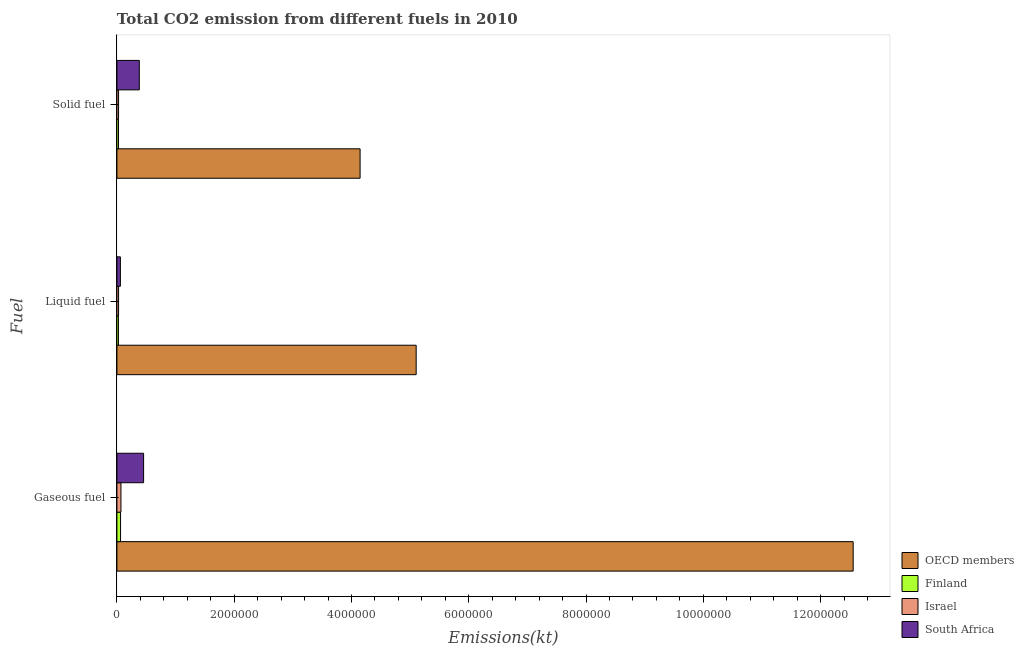How many bars are there on the 2nd tick from the bottom?
Ensure brevity in your answer.  4. What is the label of the 1st group of bars from the top?
Your response must be concise. Solid fuel. What is the amount of co2 emissions from solid fuel in South Africa?
Your response must be concise. 3.82e+05. Across all countries, what is the maximum amount of co2 emissions from solid fuel?
Offer a very short reply. 4.15e+06. Across all countries, what is the minimum amount of co2 emissions from gaseous fuel?
Offer a very short reply. 6.18e+04. In which country was the amount of co2 emissions from solid fuel minimum?
Make the answer very short. Finland. What is the total amount of co2 emissions from solid fuel in the graph?
Provide a short and direct response. 4.58e+06. What is the difference between the amount of co2 emissions from solid fuel in Finland and that in Israel?
Your response must be concise. -1166.11. What is the difference between the amount of co2 emissions from solid fuel in South Africa and the amount of co2 emissions from liquid fuel in OECD members?
Ensure brevity in your answer.  -4.72e+06. What is the average amount of co2 emissions from gaseous fuel per country?
Provide a short and direct response. 3.29e+06. What is the difference between the amount of co2 emissions from liquid fuel and amount of co2 emissions from solid fuel in OECD members?
Provide a succinct answer. 9.56e+05. What is the ratio of the amount of co2 emissions from liquid fuel in OECD members to that in South Africa?
Offer a terse response. 86.42. Is the amount of co2 emissions from solid fuel in South Africa less than that in Finland?
Your answer should be very brief. No. Is the difference between the amount of co2 emissions from solid fuel in Finland and South Africa greater than the difference between the amount of co2 emissions from gaseous fuel in Finland and South Africa?
Give a very brief answer. Yes. What is the difference between the highest and the second highest amount of co2 emissions from gaseous fuel?
Your answer should be very brief. 1.21e+07. What is the difference between the highest and the lowest amount of co2 emissions from solid fuel?
Keep it short and to the point. 4.12e+06. What does the 2nd bar from the bottom in Liquid fuel represents?
Provide a succinct answer. Finland. Is it the case that in every country, the sum of the amount of co2 emissions from gaseous fuel and amount of co2 emissions from liquid fuel is greater than the amount of co2 emissions from solid fuel?
Your response must be concise. Yes. Are all the bars in the graph horizontal?
Ensure brevity in your answer.  Yes. How many countries are there in the graph?
Your answer should be compact. 4. What is the difference between two consecutive major ticks on the X-axis?
Your answer should be compact. 2.00e+06. Are the values on the major ticks of X-axis written in scientific E-notation?
Offer a terse response. No. Does the graph contain any zero values?
Offer a very short reply. No. Where does the legend appear in the graph?
Give a very brief answer. Bottom right. How many legend labels are there?
Keep it short and to the point. 4. What is the title of the graph?
Keep it short and to the point. Total CO2 emission from different fuels in 2010. What is the label or title of the X-axis?
Offer a terse response. Emissions(kt). What is the label or title of the Y-axis?
Offer a very short reply. Fuel. What is the Emissions(kt) of OECD members in Gaseous fuel?
Give a very brief answer. 1.26e+07. What is the Emissions(kt) in Finland in Gaseous fuel?
Offer a terse response. 6.18e+04. What is the Emissions(kt) of Israel in Gaseous fuel?
Ensure brevity in your answer.  6.89e+04. What is the Emissions(kt) of South Africa in Gaseous fuel?
Provide a short and direct response. 4.55e+05. What is the Emissions(kt) of OECD members in Liquid fuel?
Your response must be concise. 5.10e+06. What is the Emissions(kt) in Finland in Liquid fuel?
Your answer should be compact. 2.56e+04. What is the Emissions(kt) of Israel in Liquid fuel?
Keep it short and to the point. 2.81e+04. What is the Emissions(kt) of South Africa in Liquid fuel?
Ensure brevity in your answer.  5.90e+04. What is the Emissions(kt) of OECD members in Solid fuel?
Offer a very short reply. 4.15e+06. What is the Emissions(kt) in Finland in Solid fuel?
Your answer should be very brief. 2.69e+04. What is the Emissions(kt) in Israel in Solid fuel?
Your answer should be very brief. 2.81e+04. What is the Emissions(kt) in South Africa in Solid fuel?
Offer a very short reply. 3.82e+05. Across all Fuel, what is the maximum Emissions(kt) of OECD members?
Keep it short and to the point. 1.26e+07. Across all Fuel, what is the maximum Emissions(kt) in Finland?
Offer a terse response. 6.18e+04. Across all Fuel, what is the maximum Emissions(kt) of Israel?
Offer a very short reply. 6.89e+04. Across all Fuel, what is the maximum Emissions(kt) in South Africa?
Your response must be concise. 4.55e+05. Across all Fuel, what is the minimum Emissions(kt) in OECD members?
Ensure brevity in your answer.  4.15e+06. Across all Fuel, what is the minimum Emissions(kt) of Finland?
Keep it short and to the point. 2.56e+04. Across all Fuel, what is the minimum Emissions(kt) in Israel?
Your answer should be compact. 2.81e+04. Across all Fuel, what is the minimum Emissions(kt) in South Africa?
Make the answer very short. 5.90e+04. What is the total Emissions(kt) in OECD members in the graph?
Make the answer very short. 2.18e+07. What is the total Emissions(kt) in Finland in the graph?
Give a very brief answer. 1.14e+05. What is the total Emissions(kt) of Israel in the graph?
Keep it short and to the point. 1.25e+05. What is the total Emissions(kt) in South Africa in the graph?
Provide a short and direct response. 8.96e+05. What is the difference between the Emissions(kt) in OECD members in Gaseous fuel and that in Liquid fuel?
Offer a very short reply. 7.45e+06. What is the difference between the Emissions(kt) in Finland in Gaseous fuel and that in Liquid fuel?
Give a very brief answer. 3.62e+04. What is the difference between the Emissions(kt) of Israel in Gaseous fuel and that in Liquid fuel?
Your response must be concise. 4.08e+04. What is the difference between the Emissions(kt) of South Africa in Gaseous fuel and that in Liquid fuel?
Provide a short and direct response. 3.96e+05. What is the difference between the Emissions(kt) of OECD members in Gaseous fuel and that in Solid fuel?
Your answer should be compact. 8.41e+06. What is the difference between the Emissions(kt) of Finland in Gaseous fuel and that in Solid fuel?
Make the answer very short. 3.49e+04. What is the difference between the Emissions(kt) in Israel in Gaseous fuel and that in Solid fuel?
Your answer should be compact. 4.08e+04. What is the difference between the Emissions(kt) of South Africa in Gaseous fuel and that in Solid fuel?
Offer a very short reply. 7.32e+04. What is the difference between the Emissions(kt) in OECD members in Liquid fuel and that in Solid fuel?
Offer a terse response. 9.56e+05. What is the difference between the Emissions(kt) of Finland in Liquid fuel and that in Solid fuel?
Your response must be concise. -1338.45. What is the difference between the Emissions(kt) of Israel in Liquid fuel and that in Solid fuel?
Your response must be concise. 36.67. What is the difference between the Emissions(kt) in South Africa in Liquid fuel and that in Solid fuel?
Your answer should be very brief. -3.23e+05. What is the difference between the Emissions(kt) of OECD members in Gaseous fuel and the Emissions(kt) of Finland in Liquid fuel?
Provide a short and direct response. 1.25e+07. What is the difference between the Emissions(kt) in OECD members in Gaseous fuel and the Emissions(kt) in Israel in Liquid fuel?
Give a very brief answer. 1.25e+07. What is the difference between the Emissions(kt) in OECD members in Gaseous fuel and the Emissions(kt) in South Africa in Liquid fuel?
Ensure brevity in your answer.  1.25e+07. What is the difference between the Emissions(kt) of Finland in Gaseous fuel and the Emissions(kt) of Israel in Liquid fuel?
Give a very brief answer. 3.37e+04. What is the difference between the Emissions(kt) of Finland in Gaseous fuel and the Emissions(kt) of South Africa in Liquid fuel?
Your response must be concise. 2794.25. What is the difference between the Emissions(kt) in Israel in Gaseous fuel and the Emissions(kt) in South Africa in Liquid fuel?
Your answer should be very brief. 9842.23. What is the difference between the Emissions(kt) in OECD members in Gaseous fuel and the Emissions(kt) in Finland in Solid fuel?
Make the answer very short. 1.25e+07. What is the difference between the Emissions(kt) in OECD members in Gaseous fuel and the Emissions(kt) in Israel in Solid fuel?
Your answer should be compact. 1.25e+07. What is the difference between the Emissions(kt) of OECD members in Gaseous fuel and the Emissions(kt) of South Africa in Solid fuel?
Provide a succinct answer. 1.22e+07. What is the difference between the Emissions(kt) of Finland in Gaseous fuel and the Emissions(kt) of Israel in Solid fuel?
Your answer should be compact. 3.37e+04. What is the difference between the Emissions(kt) of Finland in Gaseous fuel and the Emissions(kt) of South Africa in Solid fuel?
Your response must be concise. -3.20e+05. What is the difference between the Emissions(kt) in Israel in Gaseous fuel and the Emissions(kt) in South Africa in Solid fuel?
Your response must be concise. -3.13e+05. What is the difference between the Emissions(kt) of OECD members in Liquid fuel and the Emissions(kt) of Finland in Solid fuel?
Your response must be concise. 5.08e+06. What is the difference between the Emissions(kt) in OECD members in Liquid fuel and the Emissions(kt) in Israel in Solid fuel?
Your response must be concise. 5.07e+06. What is the difference between the Emissions(kt) in OECD members in Liquid fuel and the Emissions(kt) in South Africa in Solid fuel?
Provide a short and direct response. 4.72e+06. What is the difference between the Emissions(kt) of Finland in Liquid fuel and the Emissions(kt) of Israel in Solid fuel?
Make the answer very short. -2504.56. What is the difference between the Emissions(kt) of Finland in Liquid fuel and the Emissions(kt) of South Africa in Solid fuel?
Provide a succinct answer. -3.56e+05. What is the difference between the Emissions(kt) of Israel in Liquid fuel and the Emissions(kt) of South Africa in Solid fuel?
Your answer should be compact. -3.54e+05. What is the average Emissions(kt) of OECD members per Fuel?
Keep it short and to the point. 7.27e+06. What is the average Emissions(kt) of Finland per Fuel?
Provide a succinct answer. 3.81e+04. What is the average Emissions(kt) in Israel per Fuel?
Give a very brief answer. 4.17e+04. What is the average Emissions(kt) in South Africa per Fuel?
Make the answer very short. 2.99e+05. What is the difference between the Emissions(kt) of OECD members and Emissions(kt) of Finland in Gaseous fuel?
Keep it short and to the point. 1.25e+07. What is the difference between the Emissions(kt) in OECD members and Emissions(kt) in Israel in Gaseous fuel?
Your response must be concise. 1.25e+07. What is the difference between the Emissions(kt) in OECD members and Emissions(kt) in South Africa in Gaseous fuel?
Make the answer very short. 1.21e+07. What is the difference between the Emissions(kt) of Finland and Emissions(kt) of Israel in Gaseous fuel?
Keep it short and to the point. -7047.97. What is the difference between the Emissions(kt) in Finland and Emissions(kt) in South Africa in Gaseous fuel?
Make the answer very short. -3.93e+05. What is the difference between the Emissions(kt) in Israel and Emissions(kt) in South Africa in Gaseous fuel?
Keep it short and to the point. -3.86e+05. What is the difference between the Emissions(kt) in OECD members and Emissions(kt) in Finland in Liquid fuel?
Your answer should be compact. 5.08e+06. What is the difference between the Emissions(kt) in OECD members and Emissions(kt) in Israel in Liquid fuel?
Your answer should be compact. 5.07e+06. What is the difference between the Emissions(kt) in OECD members and Emissions(kt) in South Africa in Liquid fuel?
Offer a very short reply. 5.04e+06. What is the difference between the Emissions(kt) of Finland and Emissions(kt) of Israel in Liquid fuel?
Your response must be concise. -2541.23. What is the difference between the Emissions(kt) in Finland and Emissions(kt) in South Africa in Liquid fuel?
Offer a very short reply. -3.35e+04. What is the difference between the Emissions(kt) of Israel and Emissions(kt) of South Africa in Liquid fuel?
Provide a succinct answer. -3.09e+04. What is the difference between the Emissions(kt) of OECD members and Emissions(kt) of Finland in Solid fuel?
Your answer should be very brief. 4.12e+06. What is the difference between the Emissions(kt) of OECD members and Emissions(kt) of Israel in Solid fuel?
Offer a very short reply. 4.12e+06. What is the difference between the Emissions(kt) of OECD members and Emissions(kt) of South Africa in Solid fuel?
Your response must be concise. 3.76e+06. What is the difference between the Emissions(kt) in Finland and Emissions(kt) in Israel in Solid fuel?
Keep it short and to the point. -1166.11. What is the difference between the Emissions(kt) of Finland and Emissions(kt) of South Africa in Solid fuel?
Give a very brief answer. -3.55e+05. What is the difference between the Emissions(kt) in Israel and Emissions(kt) in South Africa in Solid fuel?
Give a very brief answer. -3.54e+05. What is the ratio of the Emissions(kt) of OECD members in Gaseous fuel to that in Liquid fuel?
Ensure brevity in your answer.  2.46. What is the ratio of the Emissions(kt) of Finland in Gaseous fuel to that in Liquid fuel?
Keep it short and to the point. 2.42. What is the ratio of the Emissions(kt) of Israel in Gaseous fuel to that in Liquid fuel?
Ensure brevity in your answer.  2.45. What is the ratio of the Emissions(kt) of South Africa in Gaseous fuel to that in Liquid fuel?
Your answer should be very brief. 7.7. What is the ratio of the Emissions(kt) of OECD members in Gaseous fuel to that in Solid fuel?
Your answer should be compact. 3.03. What is the ratio of the Emissions(kt) in Finland in Gaseous fuel to that in Solid fuel?
Your answer should be very brief. 2.3. What is the ratio of the Emissions(kt) of Israel in Gaseous fuel to that in Solid fuel?
Provide a short and direct response. 2.45. What is the ratio of the Emissions(kt) in South Africa in Gaseous fuel to that in Solid fuel?
Give a very brief answer. 1.19. What is the ratio of the Emissions(kt) in OECD members in Liquid fuel to that in Solid fuel?
Provide a short and direct response. 1.23. What is the ratio of the Emissions(kt) of Finland in Liquid fuel to that in Solid fuel?
Provide a short and direct response. 0.95. What is the ratio of the Emissions(kt) in South Africa in Liquid fuel to that in Solid fuel?
Make the answer very short. 0.15. What is the difference between the highest and the second highest Emissions(kt) of OECD members?
Offer a very short reply. 7.45e+06. What is the difference between the highest and the second highest Emissions(kt) of Finland?
Ensure brevity in your answer.  3.49e+04. What is the difference between the highest and the second highest Emissions(kt) in Israel?
Make the answer very short. 4.08e+04. What is the difference between the highest and the second highest Emissions(kt) in South Africa?
Offer a terse response. 7.32e+04. What is the difference between the highest and the lowest Emissions(kt) of OECD members?
Provide a succinct answer. 8.41e+06. What is the difference between the highest and the lowest Emissions(kt) in Finland?
Make the answer very short. 3.62e+04. What is the difference between the highest and the lowest Emissions(kt) in Israel?
Your answer should be very brief. 4.08e+04. What is the difference between the highest and the lowest Emissions(kt) of South Africa?
Your answer should be compact. 3.96e+05. 